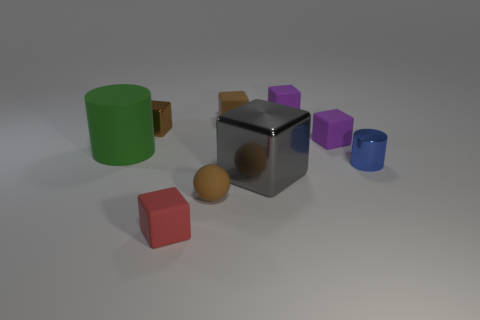Is the large metal cube the same color as the shiny cylinder?
Offer a very short reply. No. What is the size of the metal cube that is the same color as the small ball?
Offer a very short reply. Small. Do the large green thing and the purple block that is behind the small metallic block have the same material?
Keep it short and to the point. Yes. What color is the big shiny block?
Provide a succinct answer. Gray. The sphere that is the same material as the red thing is what size?
Provide a succinct answer. Small. There is a cylinder on the left side of the cylinder in front of the green thing; what number of matte balls are behind it?
Ensure brevity in your answer.  0. Do the matte cylinder and the small shiny thing that is to the right of the brown metal block have the same color?
Provide a succinct answer. No. What shape is the tiny matte object that is the same color as the rubber sphere?
Your response must be concise. Cube. What material is the cylinder that is to the right of the tiny red thing that is left of the small brown rubber object that is in front of the tiny brown rubber cube made of?
Provide a short and direct response. Metal. Is the shape of the small thing to the left of the tiny red block the same as  the gray metal thing?
Your answer should be compact. Yes. 